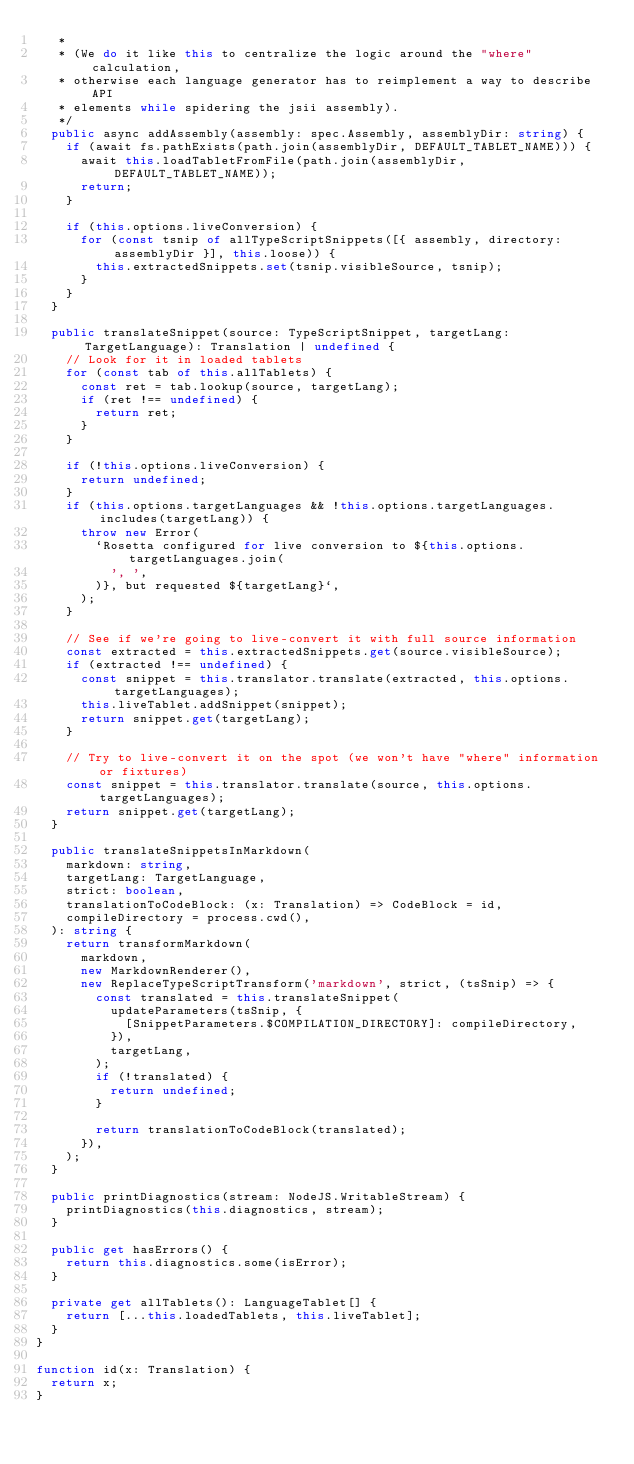Convert code to text. <code><loc_0><loc_0><loc_500><loc_500><_TypeScript_>   *
   * (We do it like this to centralize the logic around the "where" calculation,
   * otherwise each language generator has to reimplement a way to describe API
   * elements while spidering the jsii assembly).
   */
  public async addAssembly(assembly: spec.Assembly, assemblyDir: string) {
    if (await fs.pathExists(path.join(assemblyDir, DEFAULT_TABLET_NAME))) {
      await this.loadTabletFromFile(path.join(assemblyDir, DEFAULT_TABLET_NAME));
      return;
    }

    if (this.options.liveConversion) {
      for (const tsnip of allTypeScriptSnippets([{ assembly, directory: assemblyDir }], this.loose)) {
        this.extractedSnippets.set(tsnip.visibleSource, tsnip);
      }
    }
  }

  public translateSnippet(source: TypeScriptSnippet, targetLang: TargetLanguage): Translation | undefined {
    // Look for it in loaded tablets
    for (const tab of this.allTablets) {
      const ret = tab.lookup(source, targetLang);
      if (ret !== undefined) {
        return ret;
      }
    }

    if (!this.options.liveConversion) {
      return undefined;
    }
    if (this.options.targetLanguages && !this.options.targetLanguages.includes(targetLang)) {
      throw new Error(
        `Rosetta configured for live conversion to ${this.options.targetLanguages.join(
          ', ',
        )}, but requested ${targetLang}`,
      );
    }

    // See if we're going to live-convert it with full source information
    const extracted = this.extractedSnippets.get(source.visibleSource);
    if (extracted !== undefined) {
      const snippet = this.translator.translate(extracted, this.options.targetLanguages);
      this.liveTablet.addSnippet(snippet);
      return snippet.get(targetLang);
    }

    // Try to live-convert it on the spot (we won't have "where" information or fixtures)
    const snippet = this.translator.translate(source, this.options.targetLanguages);
    return snippet.get(targetLang);
  }

  public translateSnippetsInMarkdown(
    markdown: string,
    targetLang: TargetLanguage,
    strict: boolean,
    translationToCodeBlock: (x: Translation) => CodeBlock = id,
    compileDirectory = process.cwd(),
  ): string {
    return transformMarkdown(
      markdown,
      new MarkdownRenderer(),
      new ReplaceTypeScriptTransform('markdown', strict, (tsSnip) => {
        const translated = this.translateSnippet(
          updateParameters(tsSnip, {
            [SnippetParameters.$COMPILATION_DIRECTORY]: compileDirectory,
          }),
          targetLang,
        );
        if (!translated) {
          return undefined;
        }

        return translationToCodeBlock(translated);
      }),
    );
  }

  public printDiagnostics(stream: NodeJS.WritableStream) {
    printDiagnostics(this.diagnostics, stream);
  }

  public get hasErrors() {
    return this.diagnostics.some(isError);
  }

  private get allTablets(): LanguageTablet[] {
    return [...this.loadedTablets, this.liveTablet];
  }
}

function id(x: Translation) {
  return x;
}
</code> 